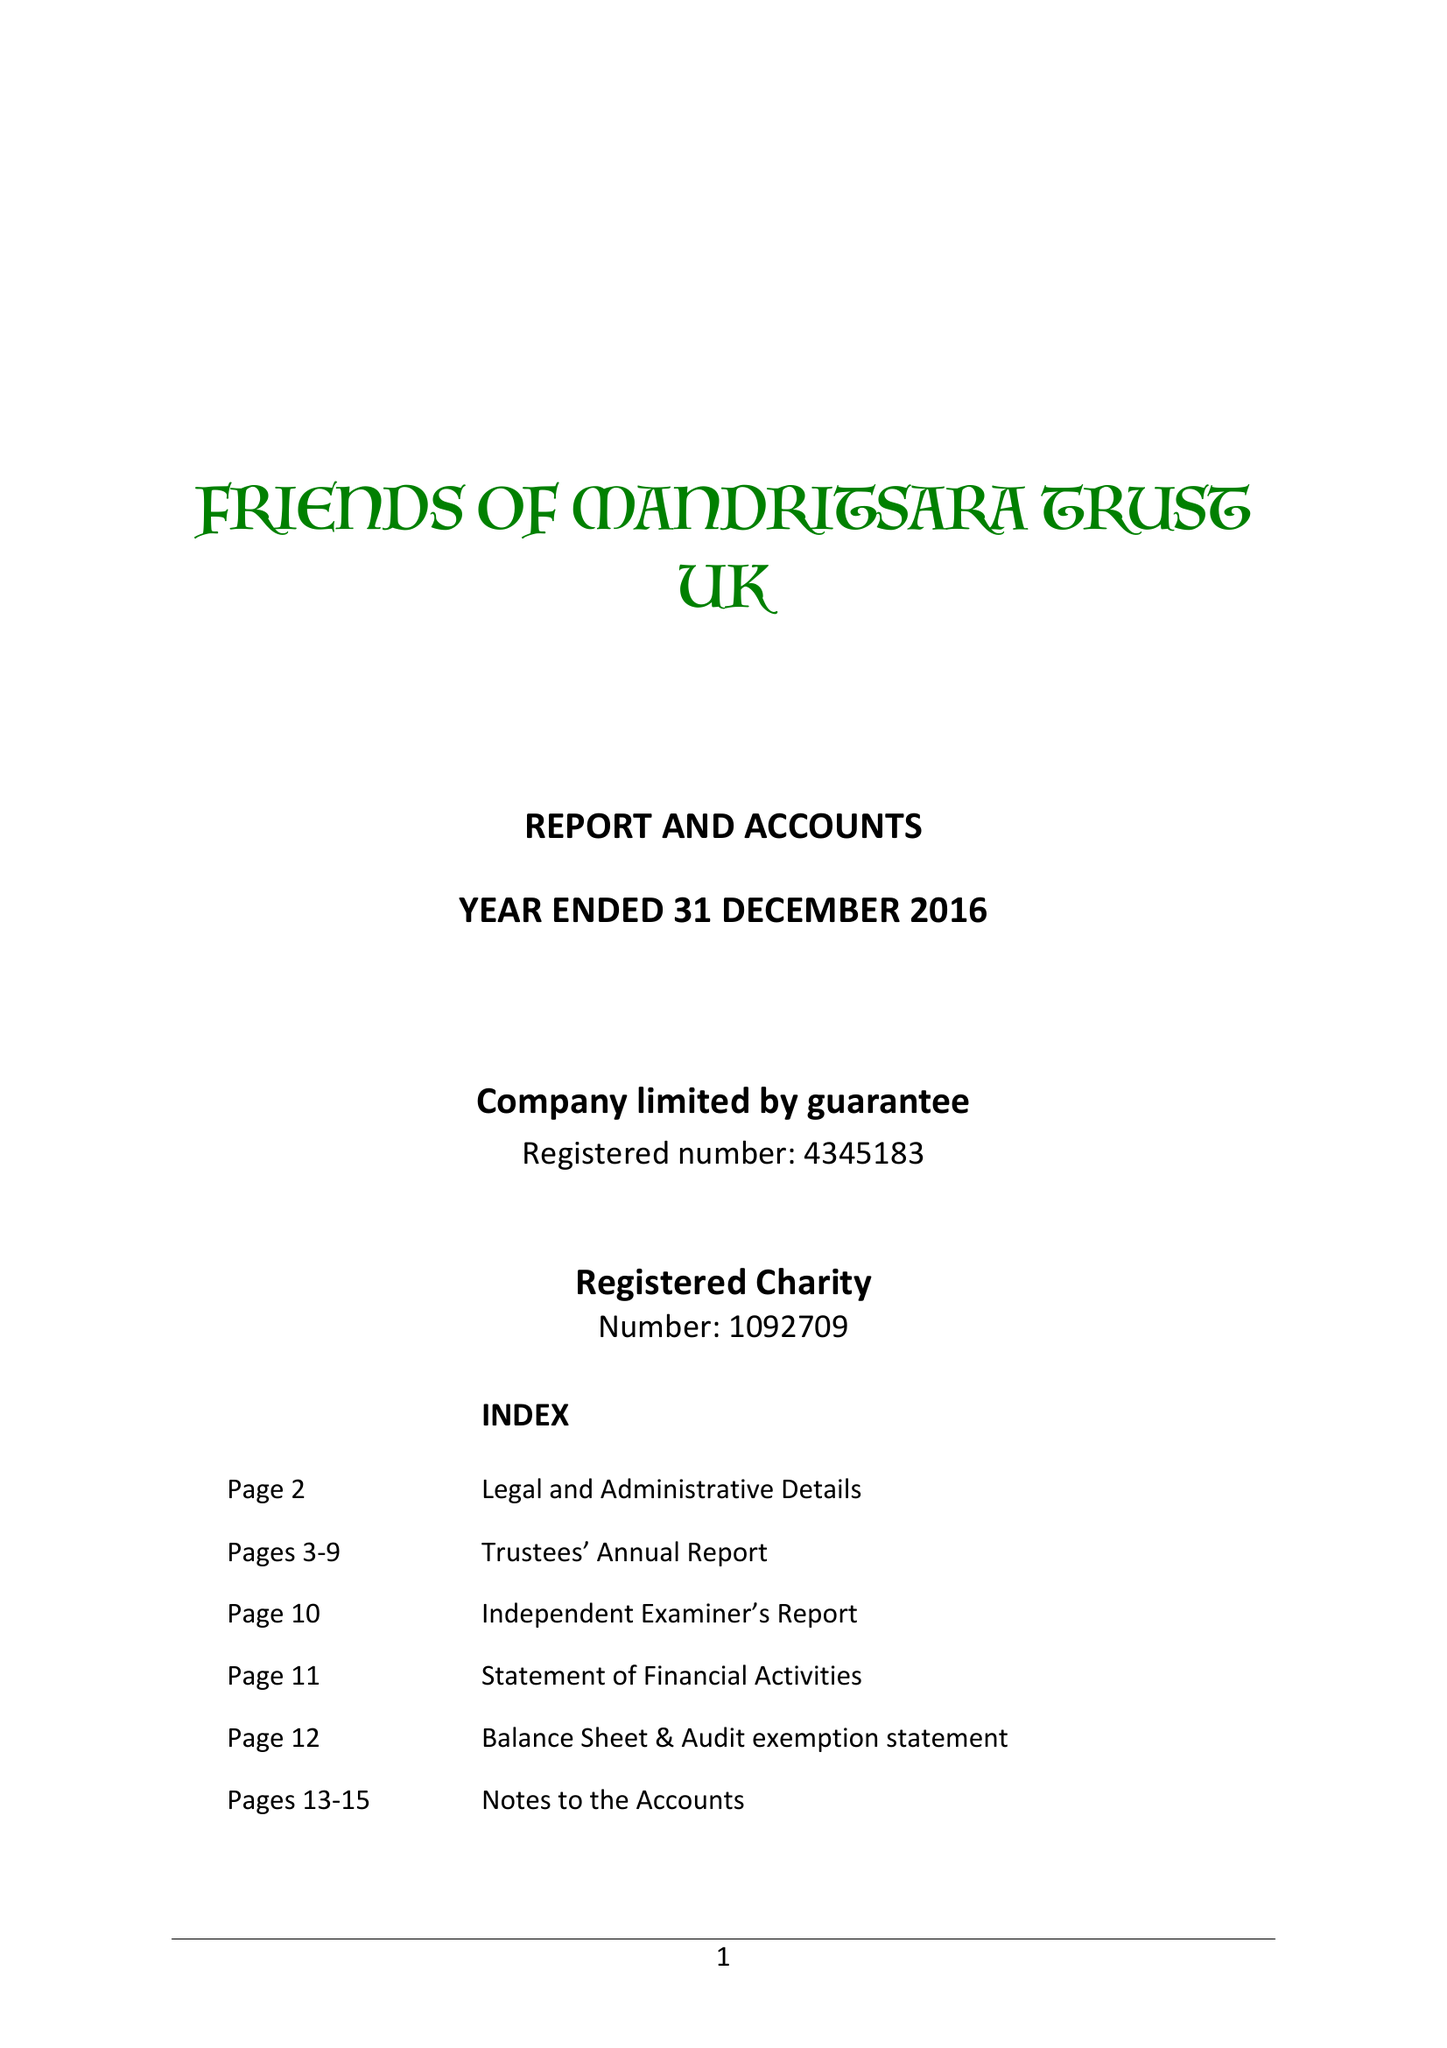What is the value for the income_annually_in_british_pounds?
Answer the question using a single word or phrase. 265140.00 